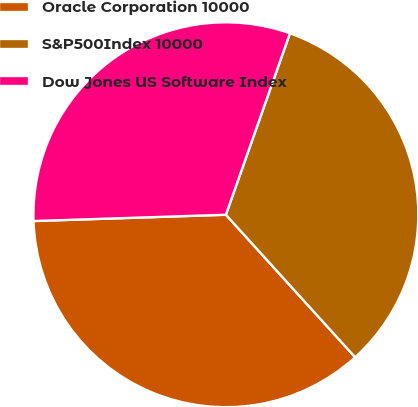Convert chart. <chart><loc_0><loc_0><loc_500><loc_500><pie_chart><fcel>Oracle Corporation 10000<fcel>S&P500Index 10000<fcel>Dow Jones US Software Index<nl><fcel>36.2%<fcel>32.87%<fcel>30.92%<nl></chart> 